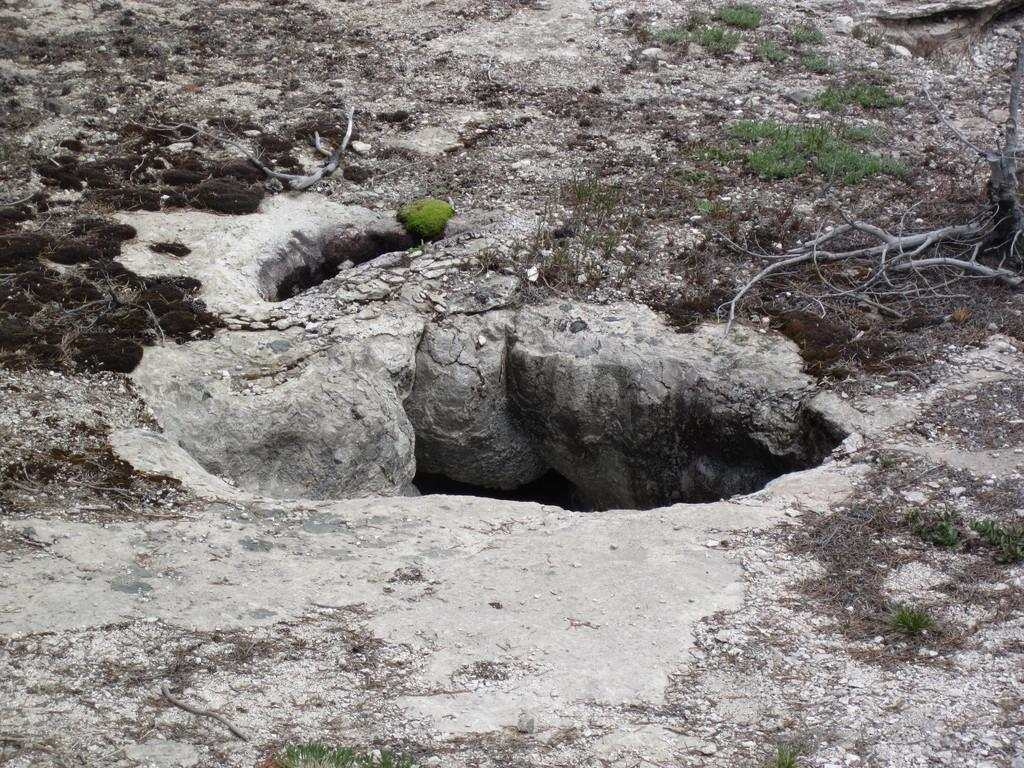What is the main feature of the image? There is a pit in the image. What type of vegetation can be seen in the image? There is grass visible in the image. What else can be seen in the image besides the pit and grass? There are stems visible in the image. What type of soup is being served in the image? There is no soup present in the image; it features a pit, grass, and stems. What question is being asked in the image? There is no question being asked in the image. --- 